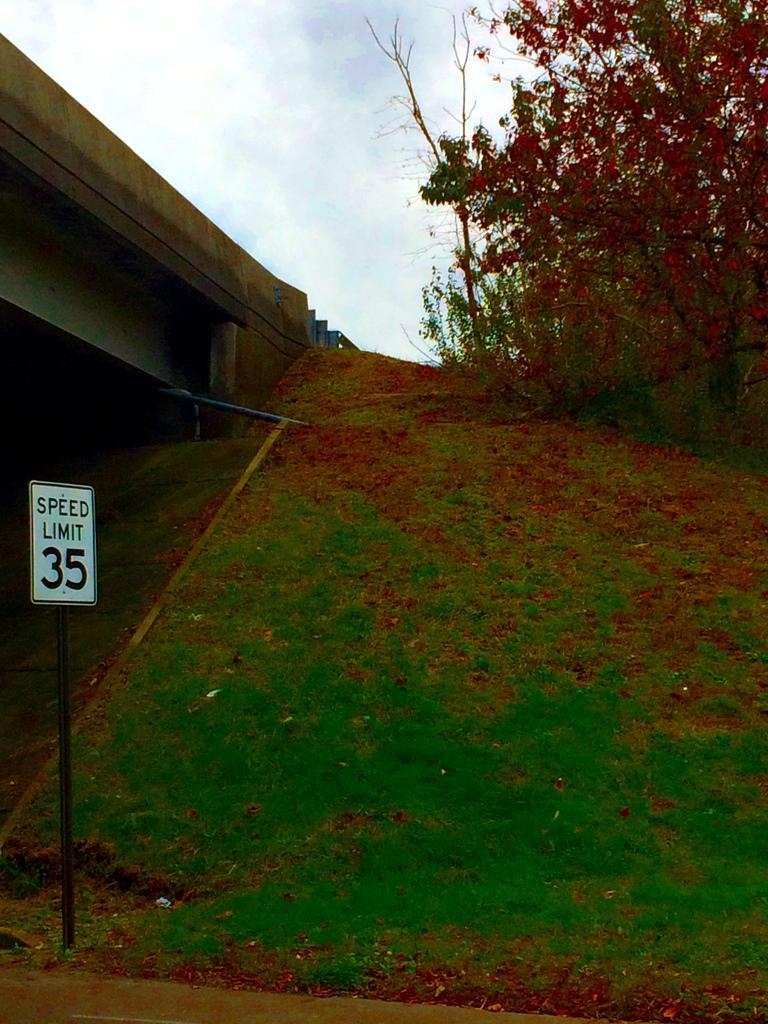Could you give a brief overview of what you see in this image? In the foreground of the picture there are dry leaves, grass and a pole. On the left there is a bridge. On the right there are trees. Sky is cloudy. 